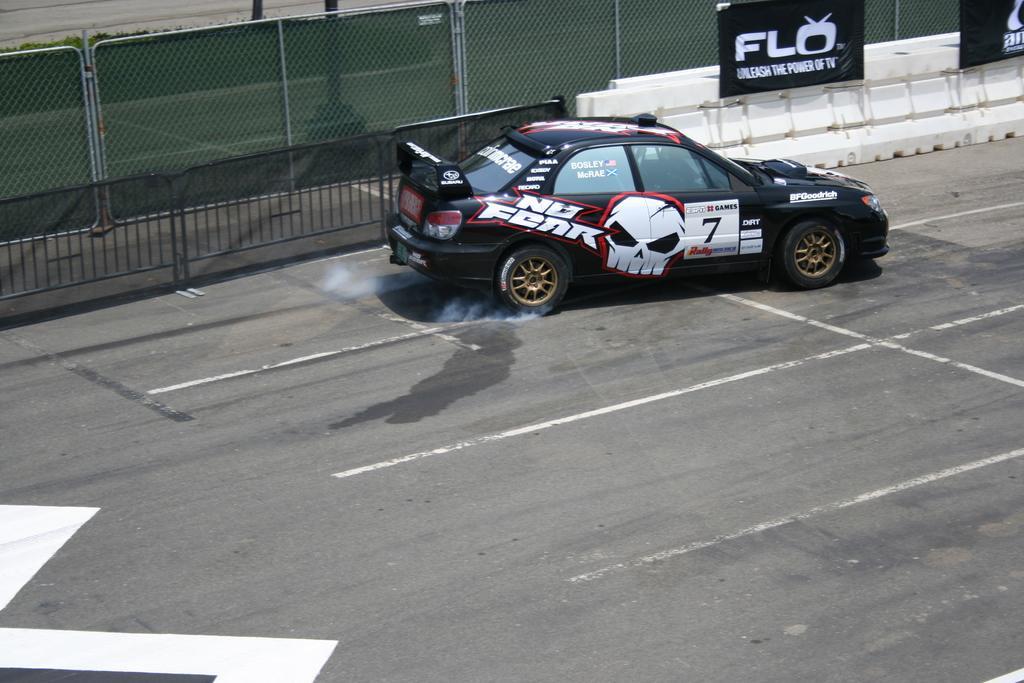Please provide a concise description of this image. In this picture there is a sports car in the image and there is a boundary and a poster at the top side of the image. 